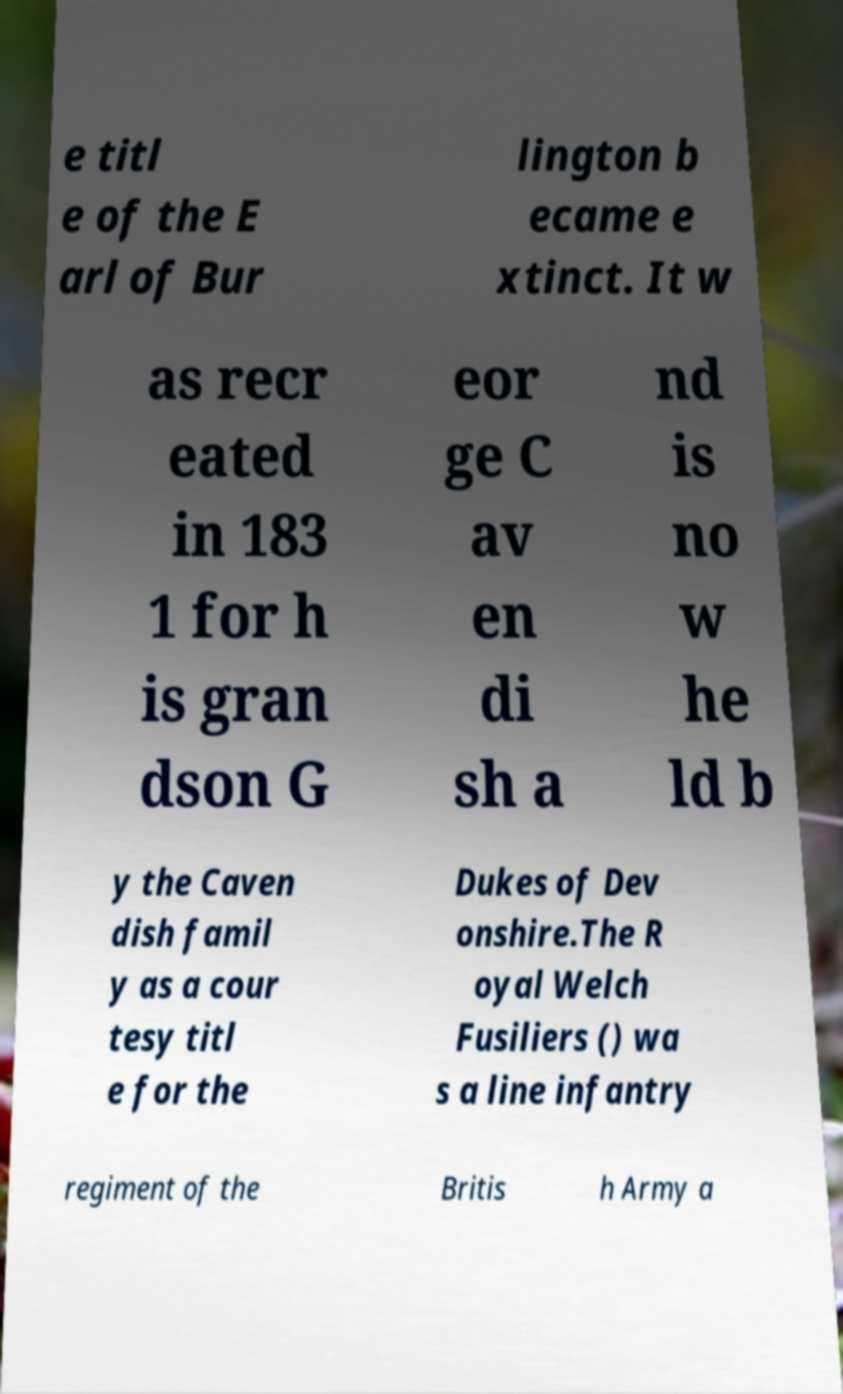I need the written content from this picture converted into text. Can you do that? e titl e of the E arl of Bur lington b ecame e xtinct. It w as recr eated in 183 1 for h is gran dson G eor ge C av en di sh a nd is no w he ld b y the Caven dish famil y as a cour tesy titl e for the Dukes of Dev onshire.The R oyal Welch Fusiliers () wa s a line infantry regiment of the Britis h Army a 